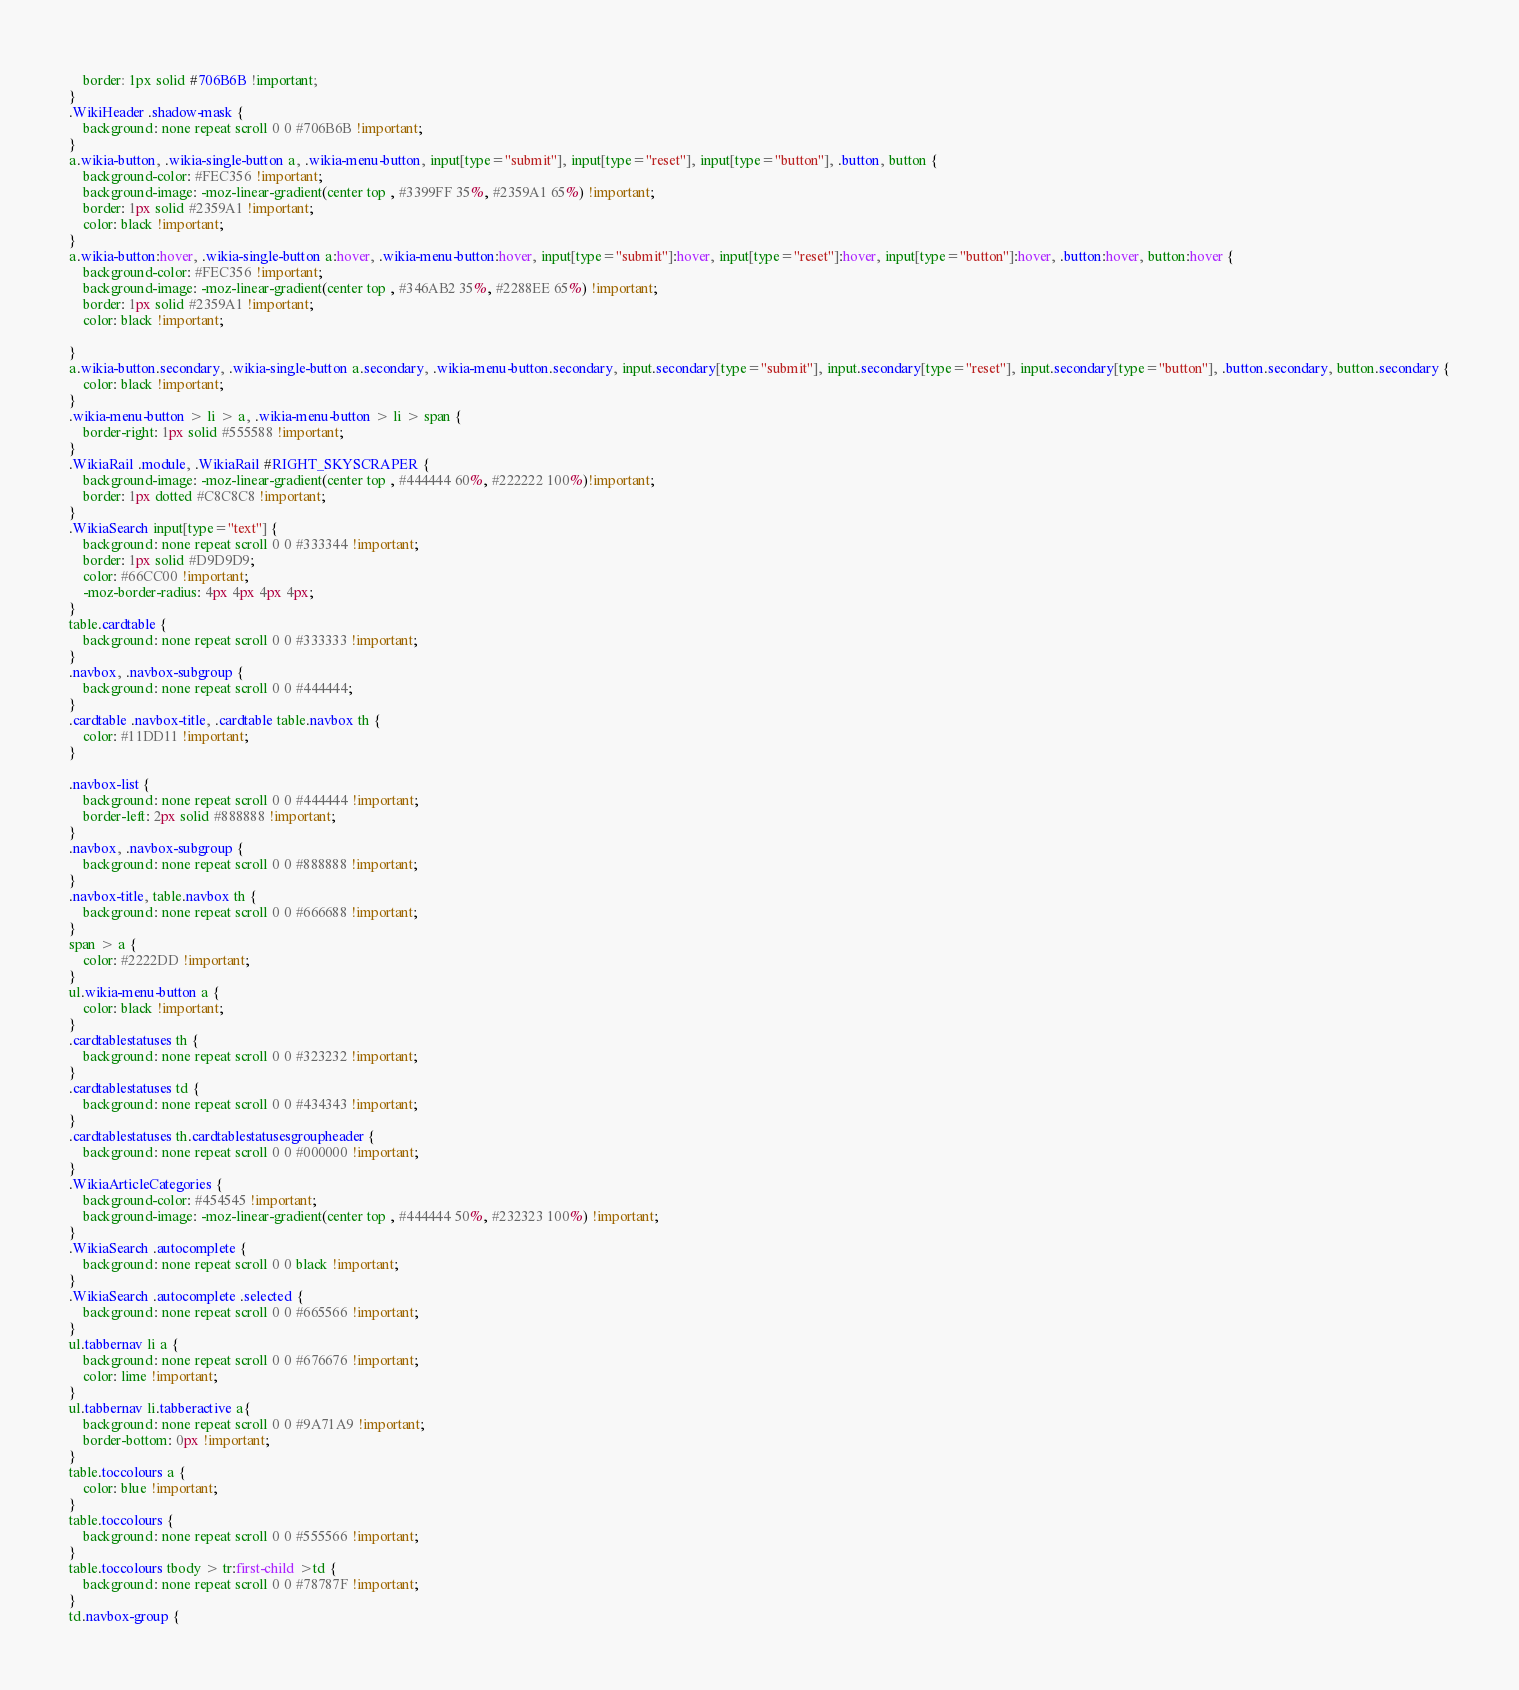<code> <loc_0><loc_0><loc_500><loc_500><_CSS_>    border: 1px solid #706B6B !important;
}
.WikiHeader .shadow-mask {
    background: none repeat scroll 0 0 #706B6B !important;
}
a.wikia-button, .wikia-single-button a, .wikia-menu-button, input[type="submit"], input[type="reset"], input[type="button"], .button, button {
    background-color: #FEC356 !important;
    background-image: -moz-linear-gradient(center top , #3399FF 35%, #2359A1 65%) !important;
    border: 1px solid #2359A1 !important;
    color: black !important;
}
a.wikia-button:hover, .wikia-single-button a:hover, .wikia-menu-button:hover, input[type="submit"]:hover, input[type="reset"]:hover, input[type="button"]:hover, .button:hover, button:hover {
    background-color: #FEC356 !important;
    background-image: -moz-linear-gradient(center top , #346AB2 35%, #2288EE 65%) !important;
    border: 1px solid #2359A1 !important;
    color: black !important;

}
a.wikia-button.secondary, .wikia-single-button a.secondary, .wikia-menu-button.secondary, input.secondary[type="submit"], input.secondary[type="reset"], input.secondary[type="button"], .button.secondary, button.secondary {
    color: black !important;
}
.wikia-menu-button > li > a, .wikia-menu-button > li > span {
    border-right: 1px solid #555588 !important;
}
.WikiaRail .module, .WikiaRail #RIGHT_SKYSCRAPER {
    background-image: -moz-linear-gradient(center top , #444444 60%, #222222 100%)!important;
    border: 1px dotted #C8C8C8 !important;
}
.WikiaSearch input[type="text"] {
    background: none repeat scroll 0 0 #333344 !important;
    border: 1px solid #D9D9D9;
    color: #66CC00 !important;
    -moz-border-radius: 4px 4px 4px 4px;
}
table.cardtable {
    background: none repeat scroll 0 0 #333333 !important;
}
.navbox, .navbox-subgroup {
    background: none repeat scroll 0 0 #444444;
}
.cardtable .navbox-title, .cardtable table.navbox th {
    color: #11DD11 !important;
}

.navbox-list {
    background: none repeat scroll 0 0 #444444 !important;
    border-left: 2px solid #888888 !important;
}
.navbox, .navbox-subgroup {
    background: none repeat scroll 0 0 #888888 !important;
}
.navbox-title, table.navbox th {
    background: none repeat scroll 0 0 #666688 !important;
}
span > a {
    color: #2222DD !important;
}
ul.wikia-menu-button a {
    color: black !important;
}
.cardtablestatuses th {
    background: none repeat scroll 0 0 #323232 !important;
}
.cardtablestatuses td {
    background: none repeat scroll 0 0 #434343 !important;
}
.cardtablestatuses th.cardtablestatusesgroupheader {
    background: none repeat scroll 0 0 #000000 !important;
}
.WikiaArticleCategories {
    background-color: #454545 !important;
    background-image: -moz-linear-gradient(center top , #444444 50%, #232323 100%) !important;
}
.WikiaSearch .autocomplete {
    background: none repeat scroll 0 0 black !important;
}
.WikiaSearch .autocomplete .selected {
    background: none repeat scroll 0 0 #665566 !important;
}
ul.tabbernav li a {
    background: none repeat scroll 0 0 #676676 !important;
    color: lime !important;
}
ul.tabbernav li.tabberactive a{
    background: none repeat scroll 0 0 #9A71A9 !important; 
    border-bottom: 0px !important;
}
table.toccolours a {
    color: blue !important;
}
table.toccolours {
    background: none repeat scroll 0 0 #555566 !important;
}
table.toccolours tbody > tr:first-child >td {
    background: none repeat scroll 0 0 #78787F !important;
}
td.navbox-group {</code> 